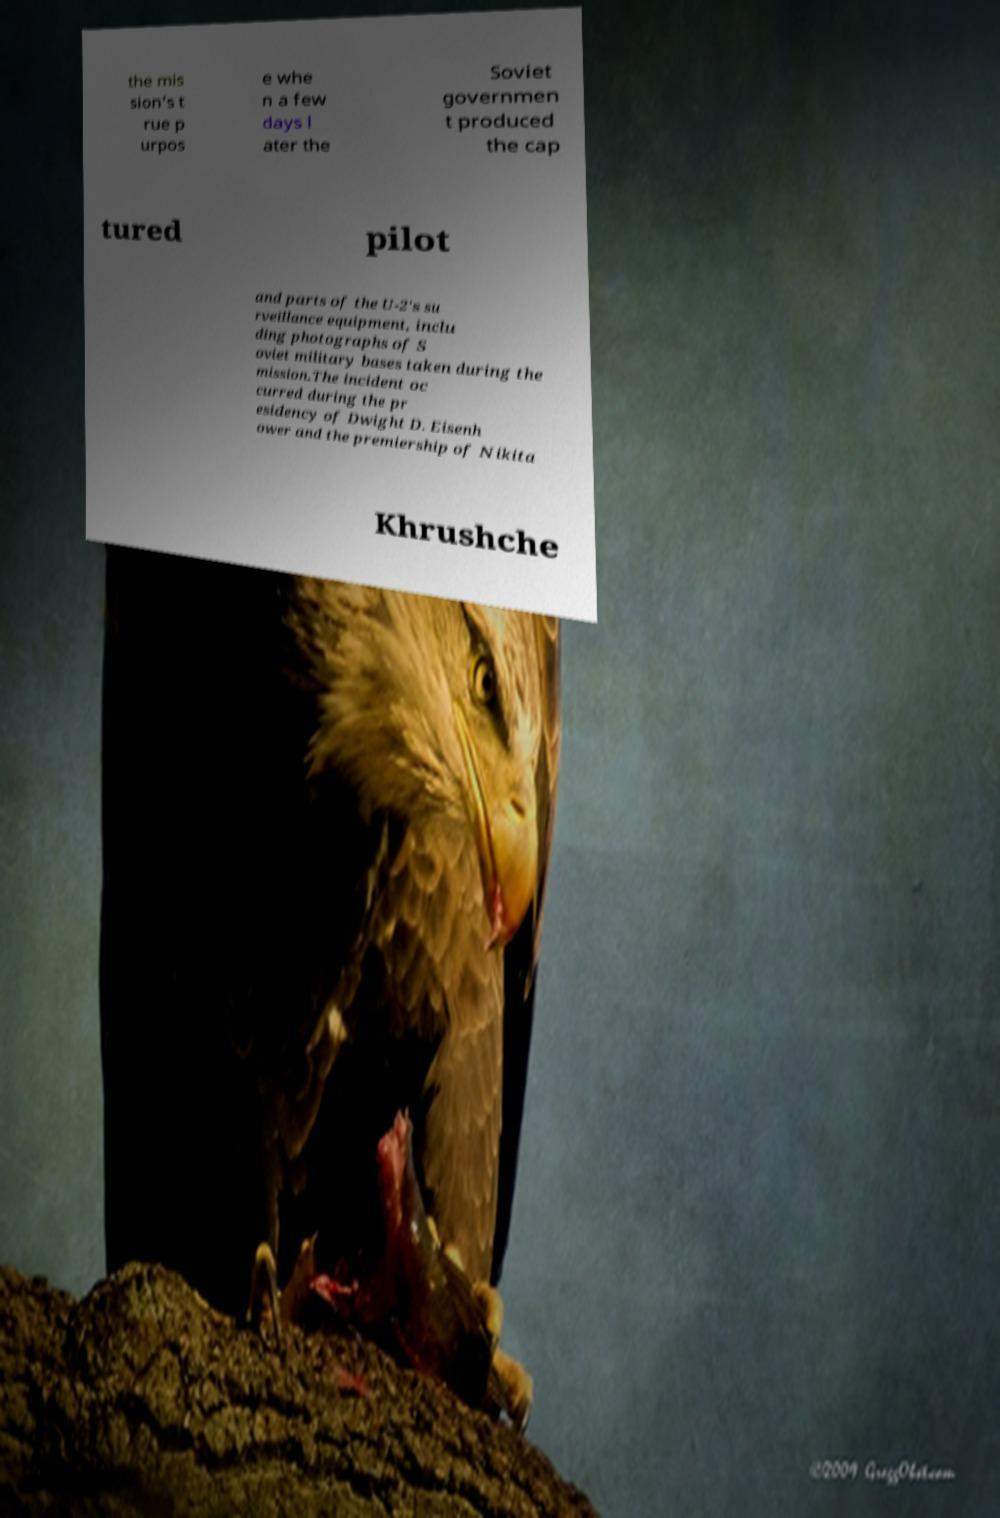I need the written content from this picture converted into text. Can you do that? the mis sion's t rue p urpos e whe n a few days l ater the Soviet governmen t produced the cap tured pilot and parts of the U-2's su rveillance equipment, inclu ding photographs of S oviet military bases taken during the mission.The incident oc curred during the pr esidency of Dwight D. Eisenh ower and the premiership of Nikita Khrushche 